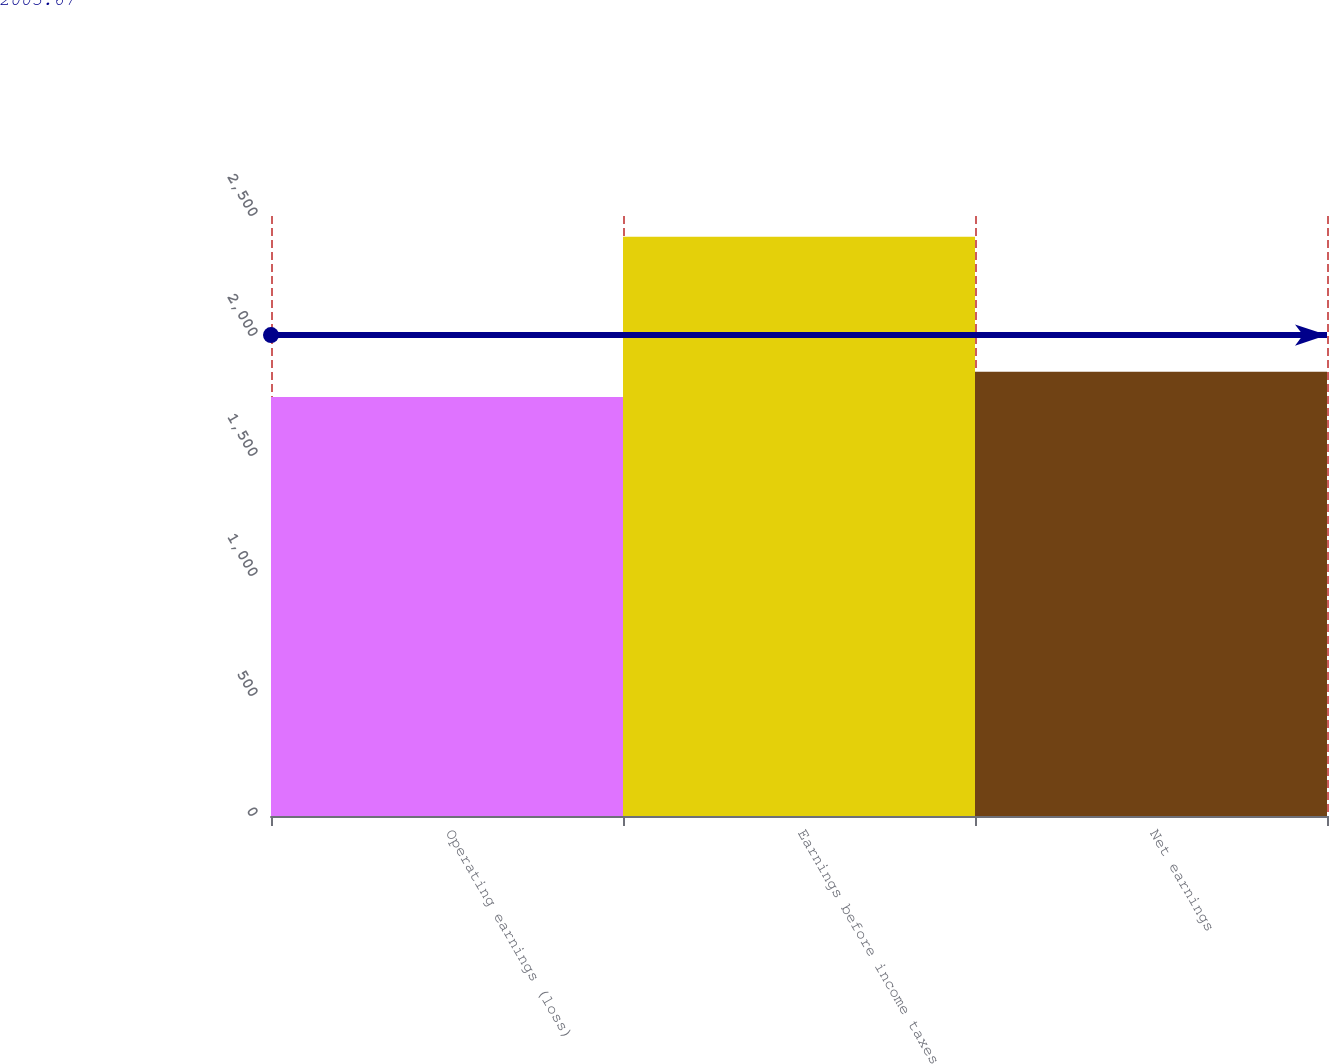<chart> <loc_0><loc_0><loc_500><loc_500><bar_chart><fcel>Operating earnings (loss)<fcel>Earnings before income taxes<fcel>Net earnings<nl><fcel>1746.2<fcel>2413.6<fcel>1851.2<nl></chart> 